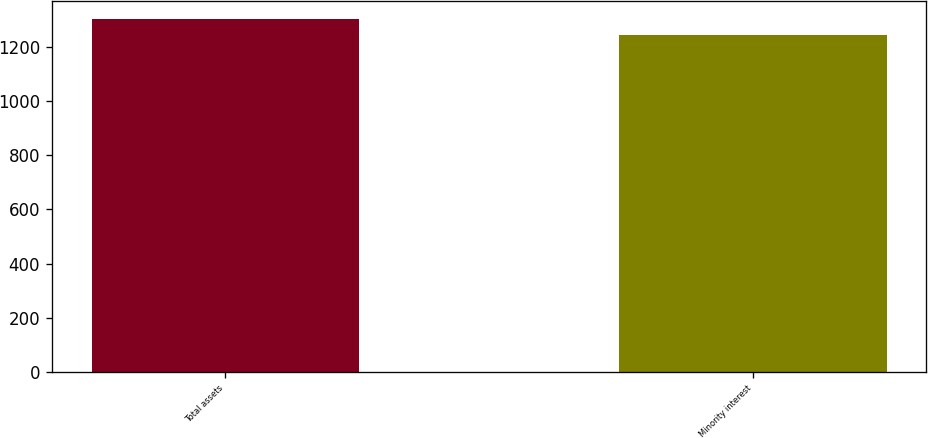<chart> <loc_0><loc_0><loc_500><loc_500><bar_chart><fcel>Total assets<fcel>Minority interest<nl><fcel>1305<fcel>1246<nl></chart> 